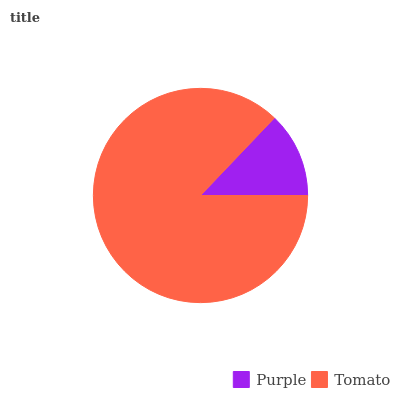Is Purple the minimum?
Answer yes or no. Yes. Is Tomato the maximum?
Answer yes or no. Yes. Is Tomato the minimum?
Answer yes or no. No. Is Tomato greater than Purple?
Answer yes or no. Yes. Is Purple less than Tomato?
Answer yes or no. Yes. Is Purple greater than Tomato?
Answer yes or no. No. Is Tomato less than Purple?
Answer yes or no. No. Is Tomato the high median?
Answer yes or no. Yes. Is Purple the low median?
Answer yes or no. Yes. Is Purple the high median?
Answer yes or no. No. Is Tomato the low median?
Answer yes or no. No. 